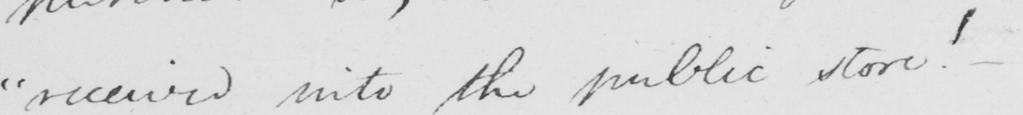Can you tell me what this handwritten text says? " received into the public store "   _ 